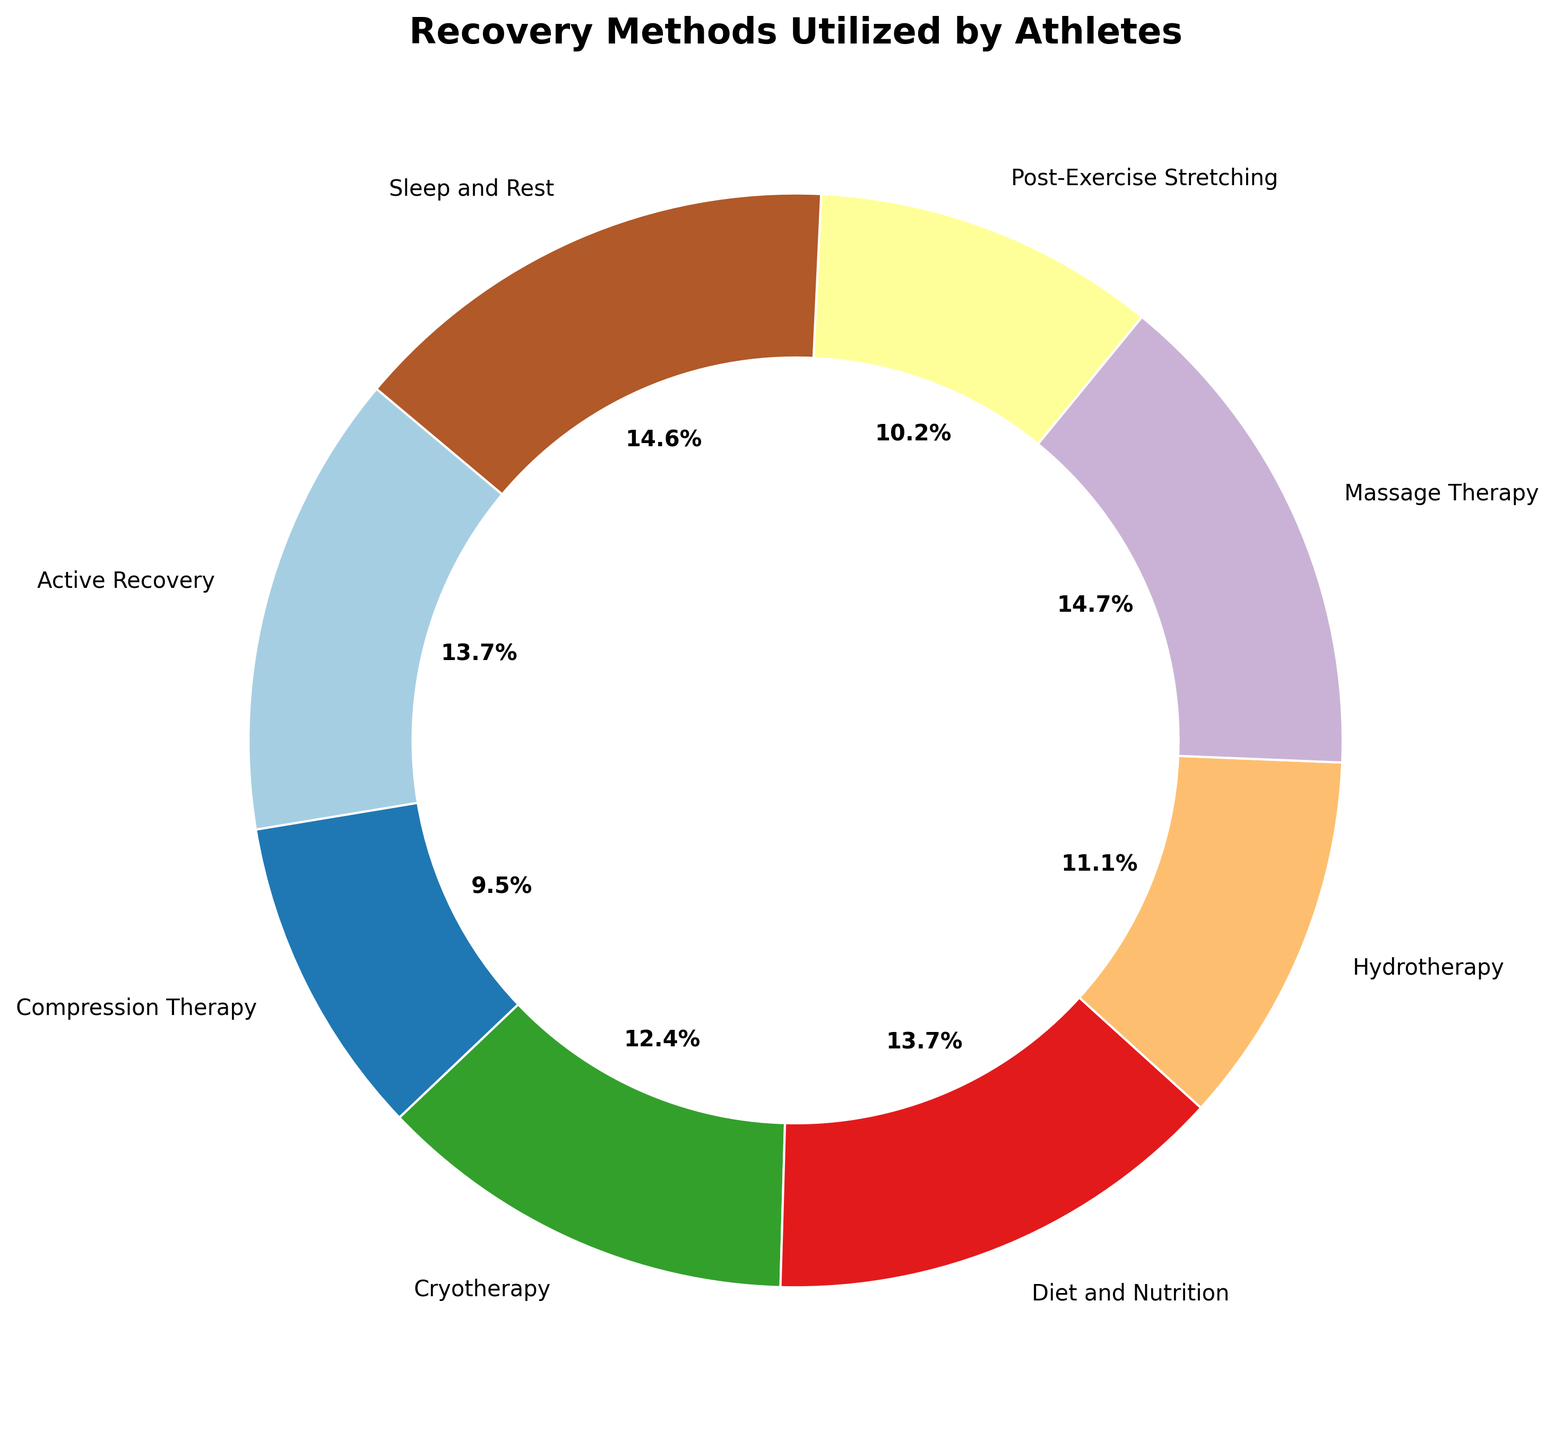What's the most utilized recovery method by athletes? To determine the most utilized recovery method, refer to the segment that has the largest proportion of the ring chart.
Answer: Sleep and Rest Which recovery method has the smallest segment in the ring chart? Identify the segment with the smallest proportion in the ring chart by comparing the size of each segment.
Answer: Compression Therapy Is the proportion of athletes using Cryotherapy greater than those using Hydrotherapy? Compare the size of the segments corresponding to Cryotherapy and Hydrotherapy in the ring chart.
Answer: Yes What is the combined percentage of athletes using Massage Therapy and Active Recovery? Locate the segments for Massage Therapy and Active Recovery, sum their percentages displayed on the chart, then convert to a total percentage. Both represented by similar-sized segments.
Answer: 42.9% How does the usage of Diet and Nutrition compare with Post-Exercise Stretching? Observe the relative sizes of the segments for Diet and Nutrition and Post-Exercise Stretching; Diet and Nutrition segment is larger.
Answer: More What percentage of athletes use Sleep and Rest? Refer to the ring chart segment labeled Sleep and Rest and read off the percent figure directly from the chart's label.
Answer: 22.7% Among Cryotherapy, Hydrotherapy, and Compression Therapy, which has the largest utilization? Compare the sizes of the segments for Cryotherapy, Hydrotherapy, and Compression Therapy; identify the segment with the largest size.
Answer: Cryotherapy Is there a method used by more than 25% of the athletes? Check the size of each segment. No single segment accounts for more than 25% based on the given segment sizes.
Answer: No How does the use of Active Recovery and Diet and Nutrition together compare with Sleep and Rest? Add the percentages of Active Recovery and Diet and Nutrition, then compare to the percentage for Sleep and Rest.
Answer: Greater 